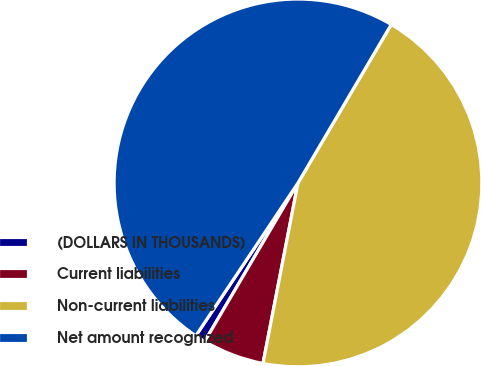Convert chart to OTSL. <chart><loc_0><loc_0><loc_500><loc_500><pie_chart><fcel>(DOLLARS IN THOUSANDS)<fcel>Current liabilities<fcel>Non-current liabilities<fcel>Net amount recognized<nl><fcel>0.91%<fcel>5.42%<fcel>44.58%<fcel>49.09%<nl></chart> 